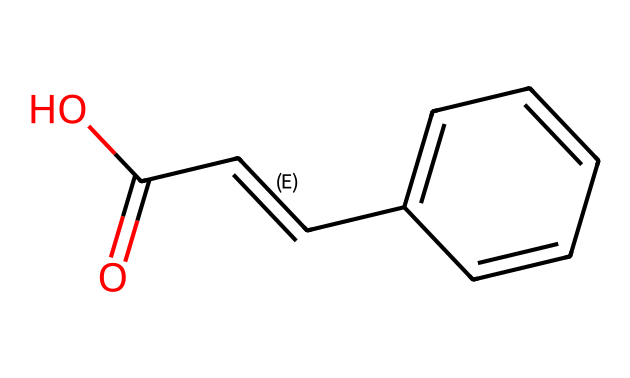How many carbon atoms are in trans-cinnamic acid? By examining the provided SMILES representation, we can count the carbon atoms represented by 'C'. Trans-cinnamic acid has 9 carbon atoms in total, including those in the ring structure of the benzene.
Answer: nine What type of bond connects the double bond in trans-cinnamic acid? The structure shows a C=C connection, which indicates a double bond between two carbon atoms. A double bond consists of one sigma bond and one pi bond.
Answer: double bond What functional group is present in trans-cinnamic acid? The presence of the '-COOH' portion in the molecular structure indicates that there is a carboxylic acid functional group present in the compound.
Answer: carboxylic acid What is the configuration of the double bond in trans-cinnamic acid? The term 'trans' in the name indicates that the substituents (the carboxylic acid and the phenyl group) attached to the double bond are on opposite sides, which is characteristic of trans-configuration.
Answer: trans How many hydrogen atoms are in trans-cinnamic acid? The number of hydrogens can be inferred from the molecular structure; each carbon typically bonds with enough hydrogens to have four total bonds. After accounting for double bonds and the carboxylic acid, trans-cinnamic acid has 8 hydrogen atoms.
Answer: eight What is the primary structural difference between trans-cinnamic acid and its cis isomer? The primary structural difference is based on the spatial arrangement of the substituents around the double bond. In the cis isomer, the substituents are on the same side of the double bond, while in trans-cinnamic acid they are on opposite sides.
Answer: spatial arrangement What type of isomerism does trans-cinnamic acid exhibit? Trans-cinnamic acid is categorized as a geometric isomer due to the different possible arrangements of atoms around its double bond, specifically distinguishing between the cis and trans forms.
Answer: geometric isomerism 